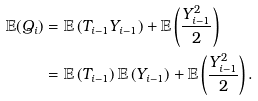<formula> <loc_0><loc_0><loc_500><loc_500>\mathbb { E } ( Q _ { i } ) & = \mathbb { E } \left ( T _ { i - 1 } Y _ { i - 1 } \right ) + \mathbb { E } \left ( \frac { Y _ { i - 1 } ^ { 2 } } { 2 } \right ) \\ & = \mathbb { E } \left ( T _ { i - 1 } \right ) \mathbb { E } \left ( Y _ { i - 1 } \right ) + \mathbb { E } \left ( \frac { Y _ { i - 1 } ^ { 2 } } { 2 } \right ) .</formula> 